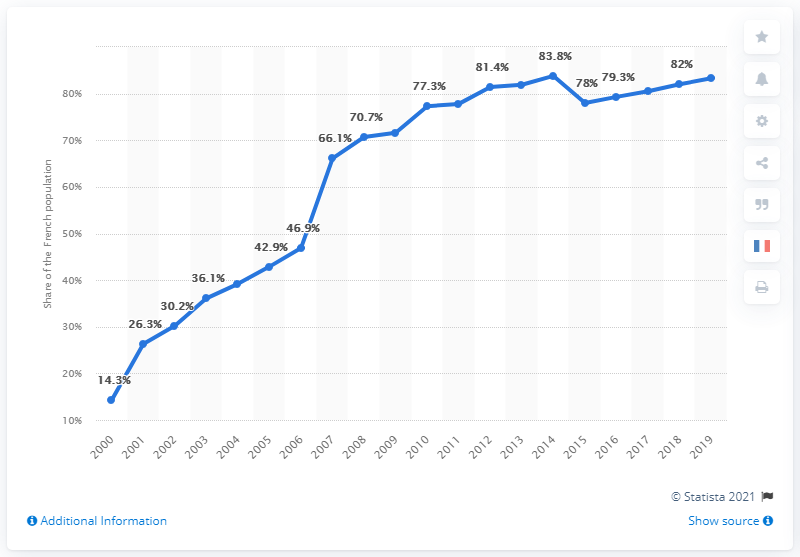Highlight a few significant elements in this photo. In 2014, nearly 84 percent of the French population had access to the internet. 